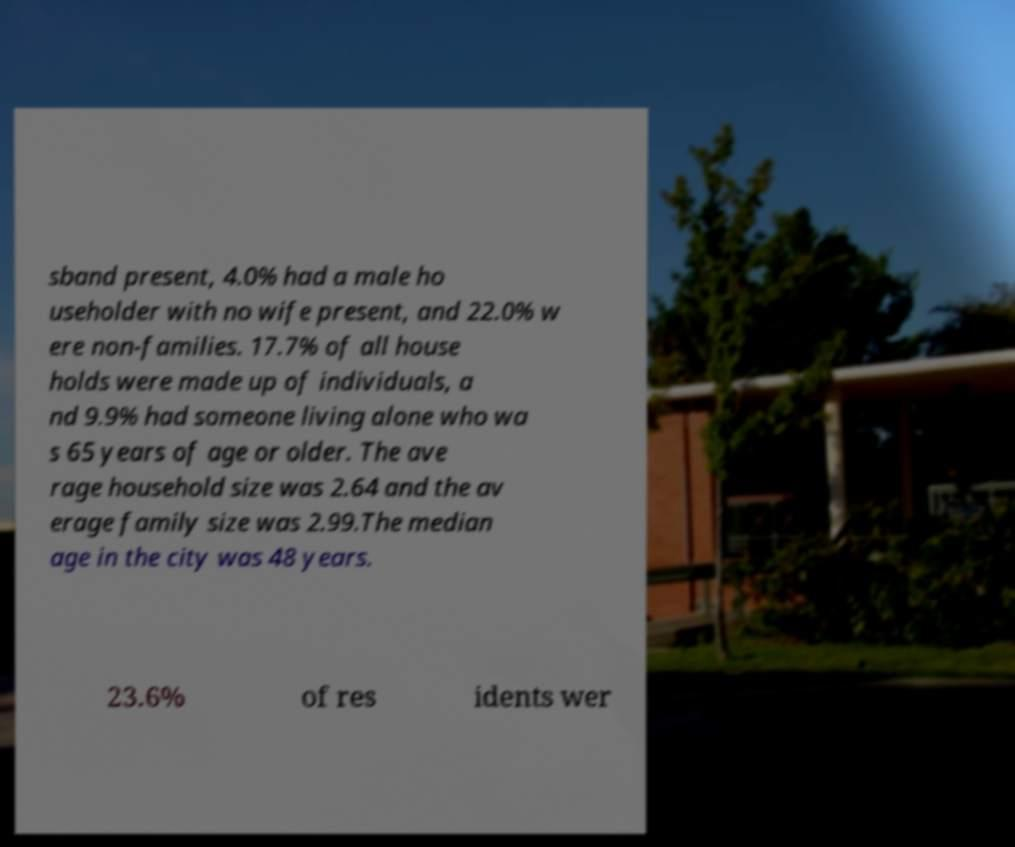What messages or text are displayed in this image? I need them in a readable, typed format. sband present, 4.0% had a male ho useholder with no wife present, and 22.0% w ere non-families. 17.7% of all house holds were made up of individuals, a nd 9.9% had someone living alone who wa s 65 years of age or older. The ave rage household size was 2.64 and the av erage family size was 2.99.The median age in the city was 48 years. 23.6% of res idents wer 